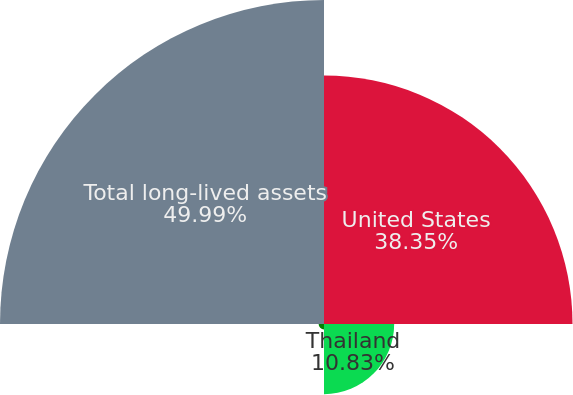Convert chart. <chart><loc_0><loc_0><loc_500><loc_500><pie_chart><fcel>United States<fcel>Thailand<fcel>Various other countries<fcel>Total long-lived assets<nl><fcel>38.35%<fcel>10.83%<fcel>0.83%<fcel>50.0%<nl></chart> 